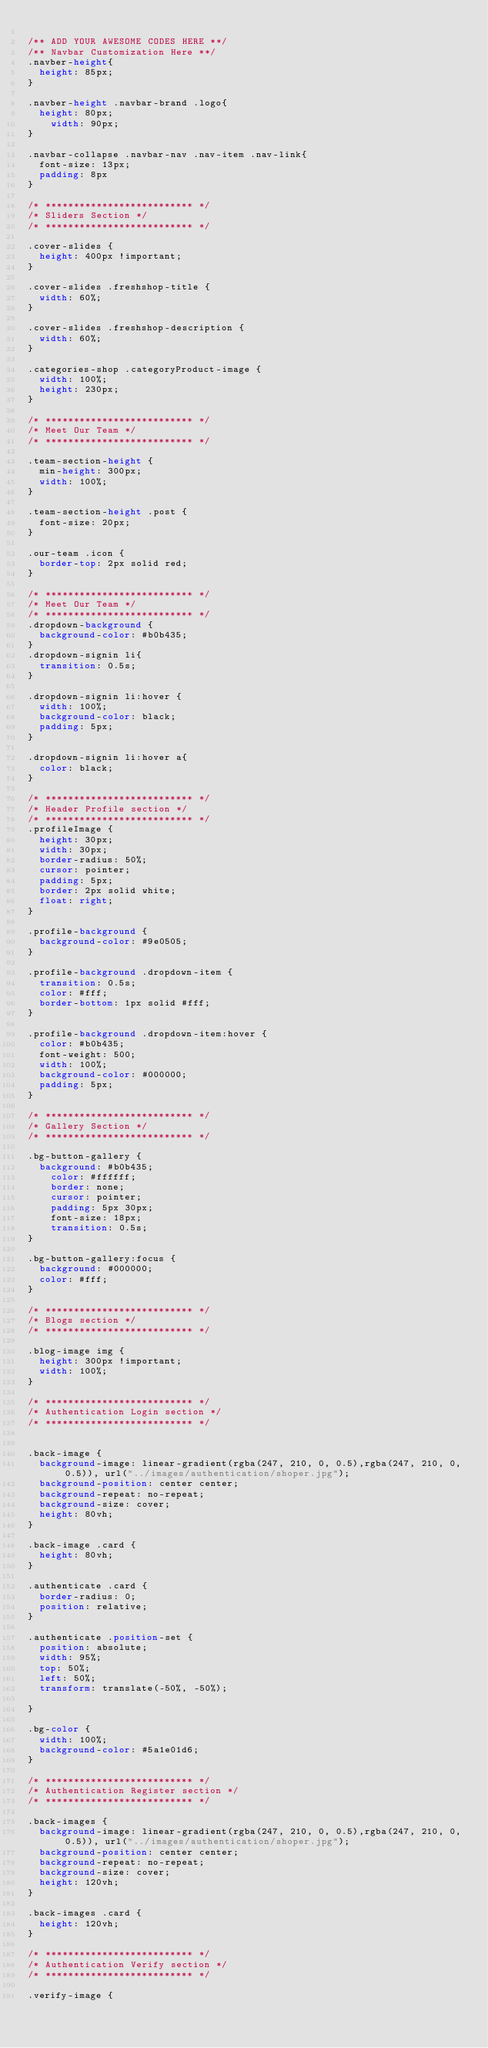Convert code to text. <code><loc_0><loc_0><loc_500><loc_500><_CSS_>
/** ADD YOUR AWESOME CODES HERE **/
/** Navbar Customization Here **/
.navber-height{
	height: 85px;
}

.navber-height .navbar-brand .logo{
	height: 80px;
    width: 90px;
}

.navbar-collapse .navbar-nav .nav-item .nav-link{
	font-size: 13px;
	padding: 8px
}

/* ************************** */
/* Sliders Section */
/* ************************** */

.cover-slides {
	height: 400px !important;
}

.cover-slides .freshshop-title {
	width: 60%;
}

.cover-slides .freshshop-description {
	width: 60%;
}

.categories-shop .categoryProduct-image {
	width: 100%;
	height: 230px;
}

/* ************************** */
/* Meet Our Team */
/* ************************** */

.team-section-height {
	min-height: 300px;
	width: 100%;
}

.team-section-height .post {
	font-size: 20px;
}

.our-team .icon {
	border-top: 2px solid red;
}

/* ************************** */
/* Meet Our Team */
/* ************************** */
.dropdown-background {
	background-color: #b0b435;
}
.dropdown-signin li{
	transition: 0.5s;
}

.dropdown-signin li:hover {
	width: 100%;
	background-color: black;
	padding: 5px;
}

.dropdown-signin li:hover a{
	color: black;
}

/* ************************** */
/* Header Profile section */
/* ************************** */
.profileImage {
	height: 30px;
	width: 30px;
	border-radius: 50%;
	cursor: pointer;
	padding: 5px;
	border: 2px solid white;
	float: right;
}

.profile-background {
	background-color: #9e0505;
}

.profile-background .dropdown-item {
	transition: 0.5s;
	color: #fff;
	border-bottom: 1px solid #fff;
}

.profile-background .dropdown-item:hover {
	color: #b0b435;
	font-weight: 500;
	width: 100%;
	background-color: #000000;
	padding: 5px;
}

/* ************************** */
/* Gallery Section */
/* ************************** */

.bg-button-gallery {
	background: #b0b435;
    color: #ffffff;
    border: none;
    cursor: pointer;
    padding: 5px 30px;
    font-size: 18px;
    transition: 0.5s;
}

.bg-button-gallery:focus {
	background: #000000;
	color: #fff;
}

/* ************************** */
/* Blogs section */
/* ************************** */

.blog-image img {
	height: 300px !important;
	width: 100%;
}

/* ************************** */
/* Authentication Login section */
/* ************************** */


.back-image {
	background-image: linear-gradient(rgba(247, 210, 0, 0.5),rgba(247, 210, 0, 0.5)), url("../images/authentication/shoper.jpg");
	background-position: center center;
	background-repeat: no-repeat; 
	background-size: cover;
	height: 80vh;
}

.back-image .card {
	height: 80vh;
}

.authenticate .card {
	border-radius: 0;
	position: relative;
}

.authenticate .position-set {
	position: absolute;
	width: 95%;
	top: 50%;
	left: 50%;
	transform: translate(-50%, -50%);

}

.bg-color {
	width: 100%;
	background-color: #5a1e01d6;
}

/* ************************** */
/* Authentication Register section */
/* ************************** */

.back-images {
	background-image: linear-gradient(rgba(247, 210, 0, 0.5),rgba(247, 210, 0, 0.5)), url("../images/authentication/shoper.jpg");
	background-position: center center;
	background-repeat: no-repeat; 
	background-size: cover;
	height: 120vh;
}

.back-images .card {
	height: 120vh;
}

/* ************************** */
/* Authentication Verify section */
/* ************************** */

.verify-image {</code> 